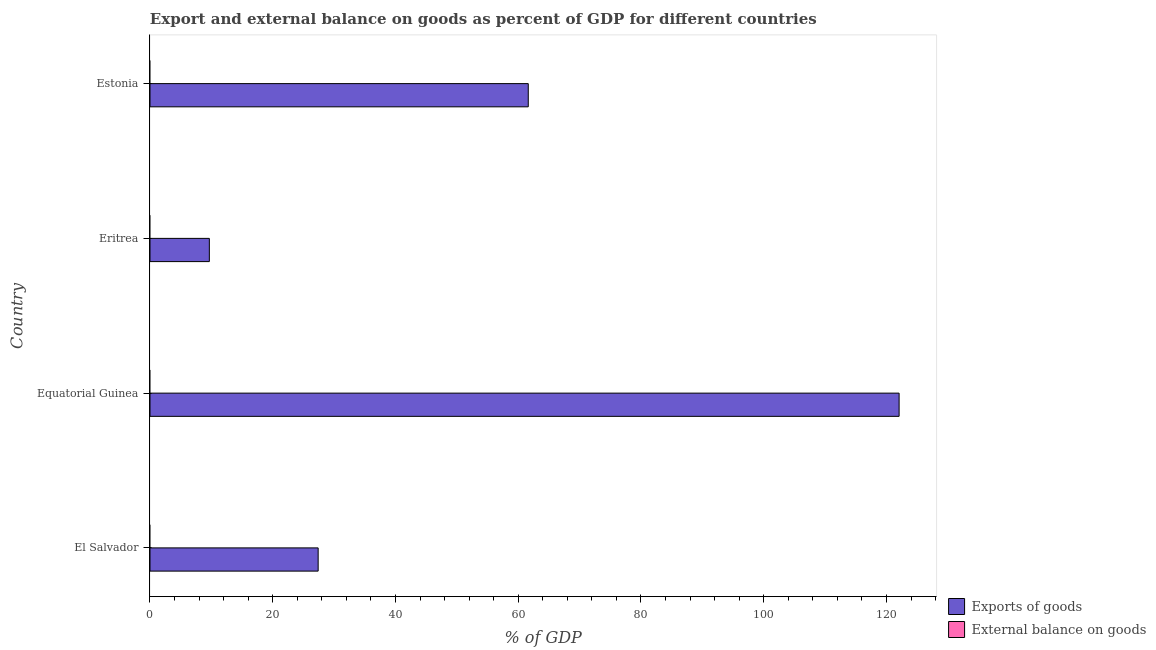How many different coloured bars are there?
Ensure brevity in your answer.  1. Are the number of bars per tick equal to the number of legend labels?
Your answer should be very brief. No. Are the number of bars on each tick of the Y-axis equal?
Ensure brevity in your answer.  Yes. How many bars are there on the 1st tick from the top?
Offer a very short reply. 1. What is the label of the 3rd group of bars from the top?
Ensure brevity in your answer.  Equatorial Guinea. What is the external balance on goods as percentage of gdp in Equatorial Guinea?
Keep it short and to the point. 0. Across all countries, what is the maximum export of goods as percentage of gdp?
Offer a very short reply. 122.06. In which country was the export of goods as percentage of gdp maximum?
Give a very brief answer. Equatorial Guinea. What is the total export of goods as percentage of gdp in the graph?
Ensure brevity in your answer.  220.77. What is the difference between the export of goods as percentage of gdp in Equatorial Guinea and that in Estonia?
Give a very brief answer. 60.43. What is the difference between the export of goods as percentage of gdp in Estonia and the external balance on goods as percentage of gdp in Equatorial Guinea?
Keep it short and to the point. 61.64. What is the average external balance on goods as percentage of gdp per country?
Offer a very short reply. 0. In how many countries, is the external balance on goods as percentage of gdp greater than 52 %?
Offer a very short reply. 0. What is the ratio of the export of goods as percentage of gdp in Eritrea to that in Estonia?
Provide a short and direct response. 0.16. Is the export of goods as percentage of gdp in Equatorial Guinea less than that in Estonia?
Ensure brevity in your answer.  No. What is the difference between the highest and the second highest export of goods as percentage of gdp?
Provide a short and direct response. 60.43. What is the difference between the highest and the lowest export of goods as percentage of gdp?
Offer a very short reply. 112.39. In how many countries, is the export of goods as percentage of gdp greater than the average export of goods as percentage of gdp taken over all countries?
Provide a succinct answer. 2. How many bars are there?
Your answer should be very brief. 4. How many countries are there in the graph?
Keep it short and to the point. 4. What is the difference between two consecutive major ticks on the X-axis?
Make the answer very short. 20. Does the graph contain any zero values?
Your answer should be very brief. Yes. Does the graph contain grids?
Ensure brevity in your answer.  No. How many legend labels are there?
Ensure brevity in your answer.  2. How are the legend labels stacked?
Provide a short and direct response. Vertical. What is the title of the graph?
Your response must be concise. Export and external balance on goods as percent of GDP for different countries. Does "Under-5(female)" appear as one of the legend labels in the graph?
Your answer should be very brief. No. What is the label or title of the X-axis?
Ensure brevity in your answer.  % of GDP. What is the % of GDP of Exports of goods in El Salvador?
Make the answer very short. 27.4. What is the % of GDP in External balance on goods in El Salvador?
Your answer should be compact. 0. What is the % of GDP of Exports of goods in Equatorial Guinea?
Provide a short and direct response. 122.06. What is the % of GDP of External balance on goods in Equatorial Guinea?
Your answer should be compact. 0. What is the % of GDP in Exports of goods in Eritrea?
Keep it short and to the point. 9.67. What is the % of GDP in External balance on goods in Eritrea?
Your answer should be very brief. 0. What is the % of GDP of Exports of goods in Estonia?
Your answer should be very brief. 61.64. What is the % of GDP in External balance on goods in Estonia?
Ensure brevity in your answer.  0. Across all countries, what is the maximum % of GDP of Exports of goods?
Offer a very short reply. 122.06. Across all countries, what is the minimum % of GDP of Exports of goods?
Your answer should be very brief. 9.67. What is the total % of GDP in Exports of goods in the graph?
Provide a succinct answer. 220.77. What is the total % of GDP of External balance on goods in the graph?
Provide a short and direct response. 0. What is the difference between the % of GDP of Exports of goods in El Salvador and that in Equatorial Guinea?
Make the answer very short. -94.66. What is the difference between the % of GDP in Exports of goods in El Salvador and that in Eritrea?
Offer a very short reply. 17.73. What is the difference between the % of GDP in Exports of goods in El Salvador and that in Estonia?
Keep it short and to the point. -34.24. What is the difference between the % of GDP in Exports of goods in Equatorial Guinea and that in Eritrea?
Your response must be concise. 112.39. What is the difference between the % of GDP in Exports of goods in Equatorial Guinea and that in Estonia?
Your answer should be compact. 60.43. What is the difference between the % of GDP of Exports of goods in Eritrea and that in Estonia?
Provide a succinct answer. -51.97. What is the average % of GDP of Exports of goods per country?
Your response must be concise. 55.19. What is the ratio of the % of GDP of Exports of goods in El Salvador to that in Equatorial Guinea?
Your answer should be very brief. 0.22. What is the ratio of the % of GDP in Exports of goods in El Salvador to that in Eritrea?
Provide a succinct answer. 2.83. What is the ratio of the % of GDP in Exports of goods in El Salvador to that in Estonia?
Ensure brevity in your answer.  0.44. What is the ratio of the % of GDP of Exports of goods in Equatorial Guinea to that in Eritrea?
Your answer should be very brief. 12.62. What is the ratio of the % of GDP in Exports of goods in Equatorial Guinea to that in Estonia?
Keep it short and to the point. 1.98. What is the ratio of the % of GDP of Exports of goods in Eritrea to that in Estonia?
Offer a very short reply. 0.16. What is the difference between the highest and the second highest % of GDP in Exports of goods?
Your response must be concise. 60.43. What is the difference between the highest and the lowest % of GDP of Exports of goods?
Provide a short and direct response. 112.39. 